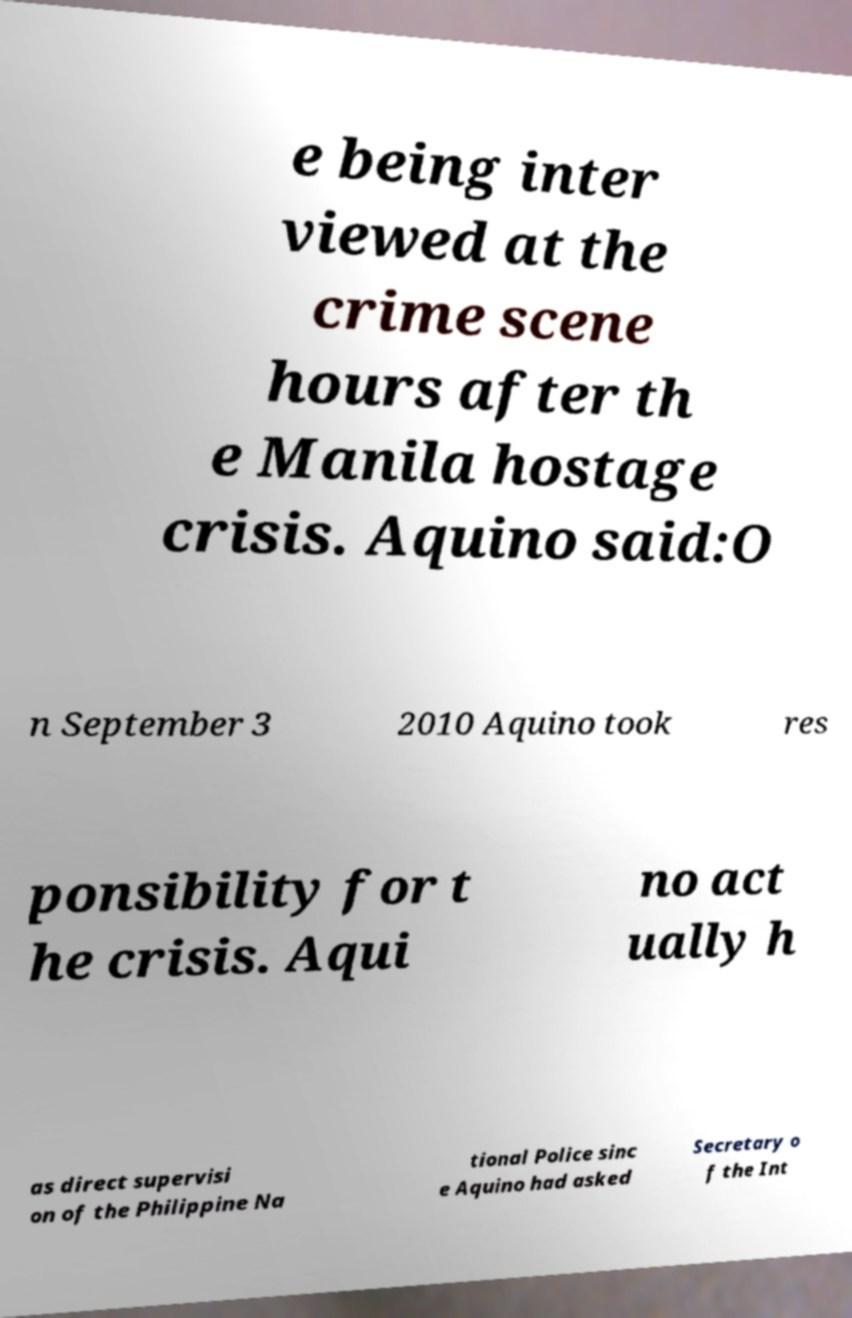Please identify and transcribe the text found in this image. e being inter viewed at the crime scene hours after th e Manila hostage crisis. Aquino said:O n September 3 2010 Aquino took res ponsibility for t he crisis. Aqui no act ually h as direct supervisi on of the Philippine Na tional Police sinc e Aquino had asked Secretary o f the Int 